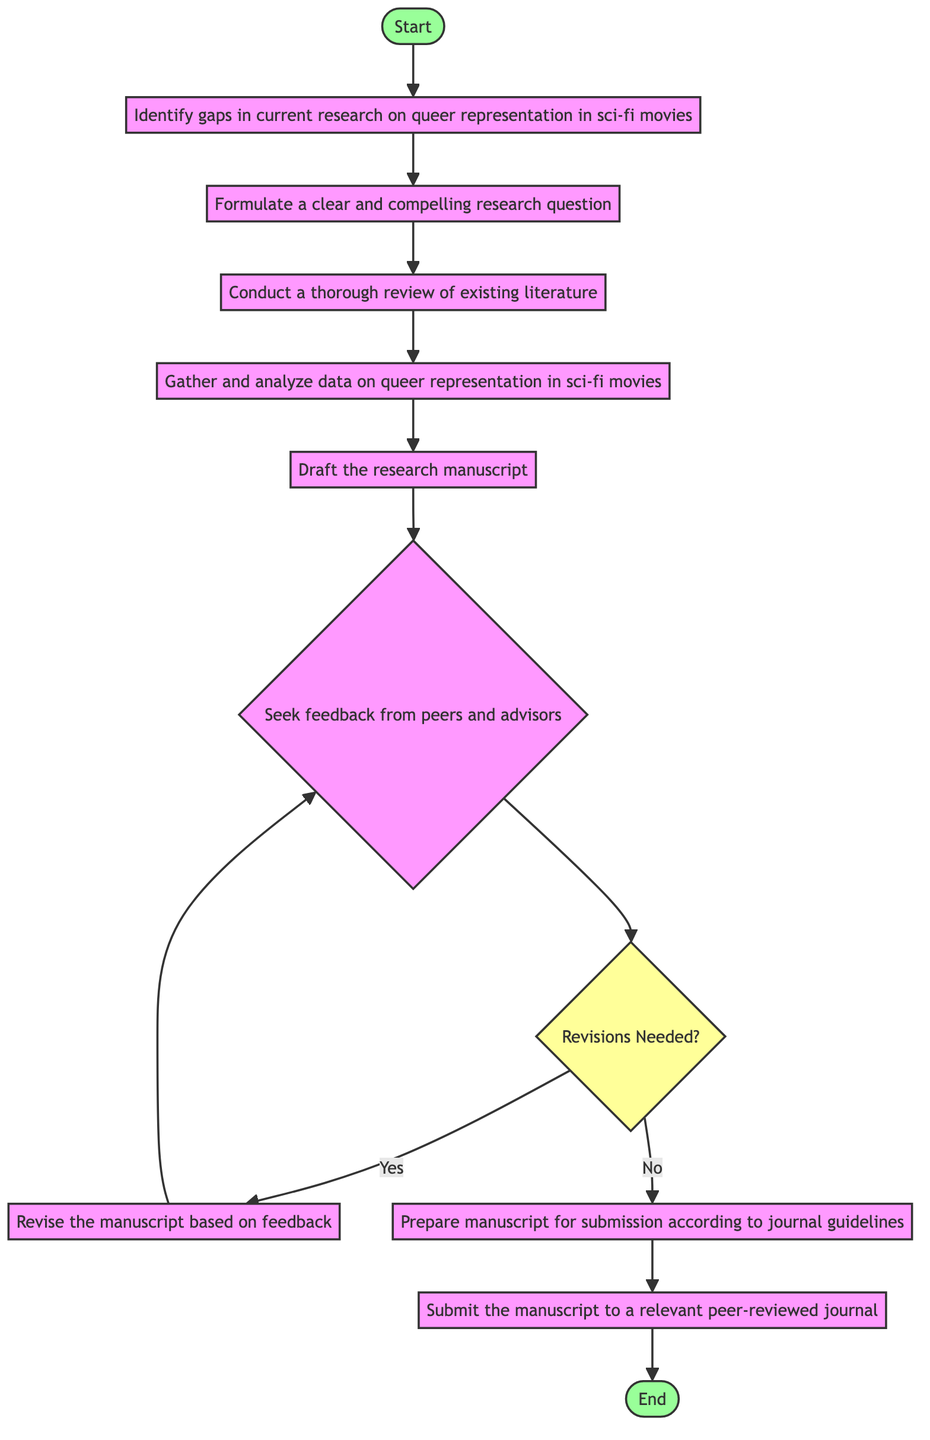What is the first step in the activity diagram? The first step is "Identify gaps in current research on queer representation in sci-fi movies," which comes immediately after the "Start" node.
Answer: Identify gaps in current research on queer representation in sci-fi movies How many nodes are there in total? By counting all the activities and decision nodes, there are a total of 9 nodes in the diagram.
Answer: 9 What is the decision point in the diagram? The decision point is about whether revisions are needed after seeking peer feedback. This is represented with a diamond shape labeled "Revisions Needed?"
Answer: Revisions Needed? What follows after gathering and analyzing data? After "Gather and analyze data on queer representation in sci-fi movies," the next step is to "Draft the research manuscript."
Answer: Draft the research manuscript What happens if revisions are needed? If revisions are needed, the process leads to "Revise the manuscript based on feedback," which is a subsequent step back into the cycle of feedback and revision.
Answer: Revise the manuscript based on feedback What is the last action before the process ends? The last action before reaching the end is "Submit the manuscript to a relevant peer-reviewed journal."
Answer: Submit the manuscript to a relevant peer-reviewed journal Which step leads directly to preparing for submission? The step that leads directly to "Prepare manuscript for submission according to journal guidelines" follows "No" from the decision "Revisions Needed?"
Answer: Prepare manuscript for submission according to journal guidelines How does the activity diagram start and end? The activity diagram starts with "Start" and ends with "End," showing a clear progression from initiation to conclusion.
Answer: Start and End What action is taken after formulating a research question? After formulating a research question, the next action taken is "Conduct a thorough review of existing literature."
Answer: Conduct a thorough review of existing literature 